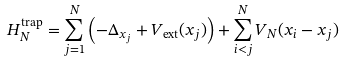<formula> <loc_0><loc_0><loc_500><loc_500>H _ { N } ^ { \text {trap} } = \sum _ { j = 1 } ^ { N } \left ( - \Delta _ { x _ { j } } + V _ { \text {ext} } ( x _ { j } ) \right ) + \sum _ { i < j } ^ { N } V _ { N } ( x _ { i } - x _ { j } )</formula> 